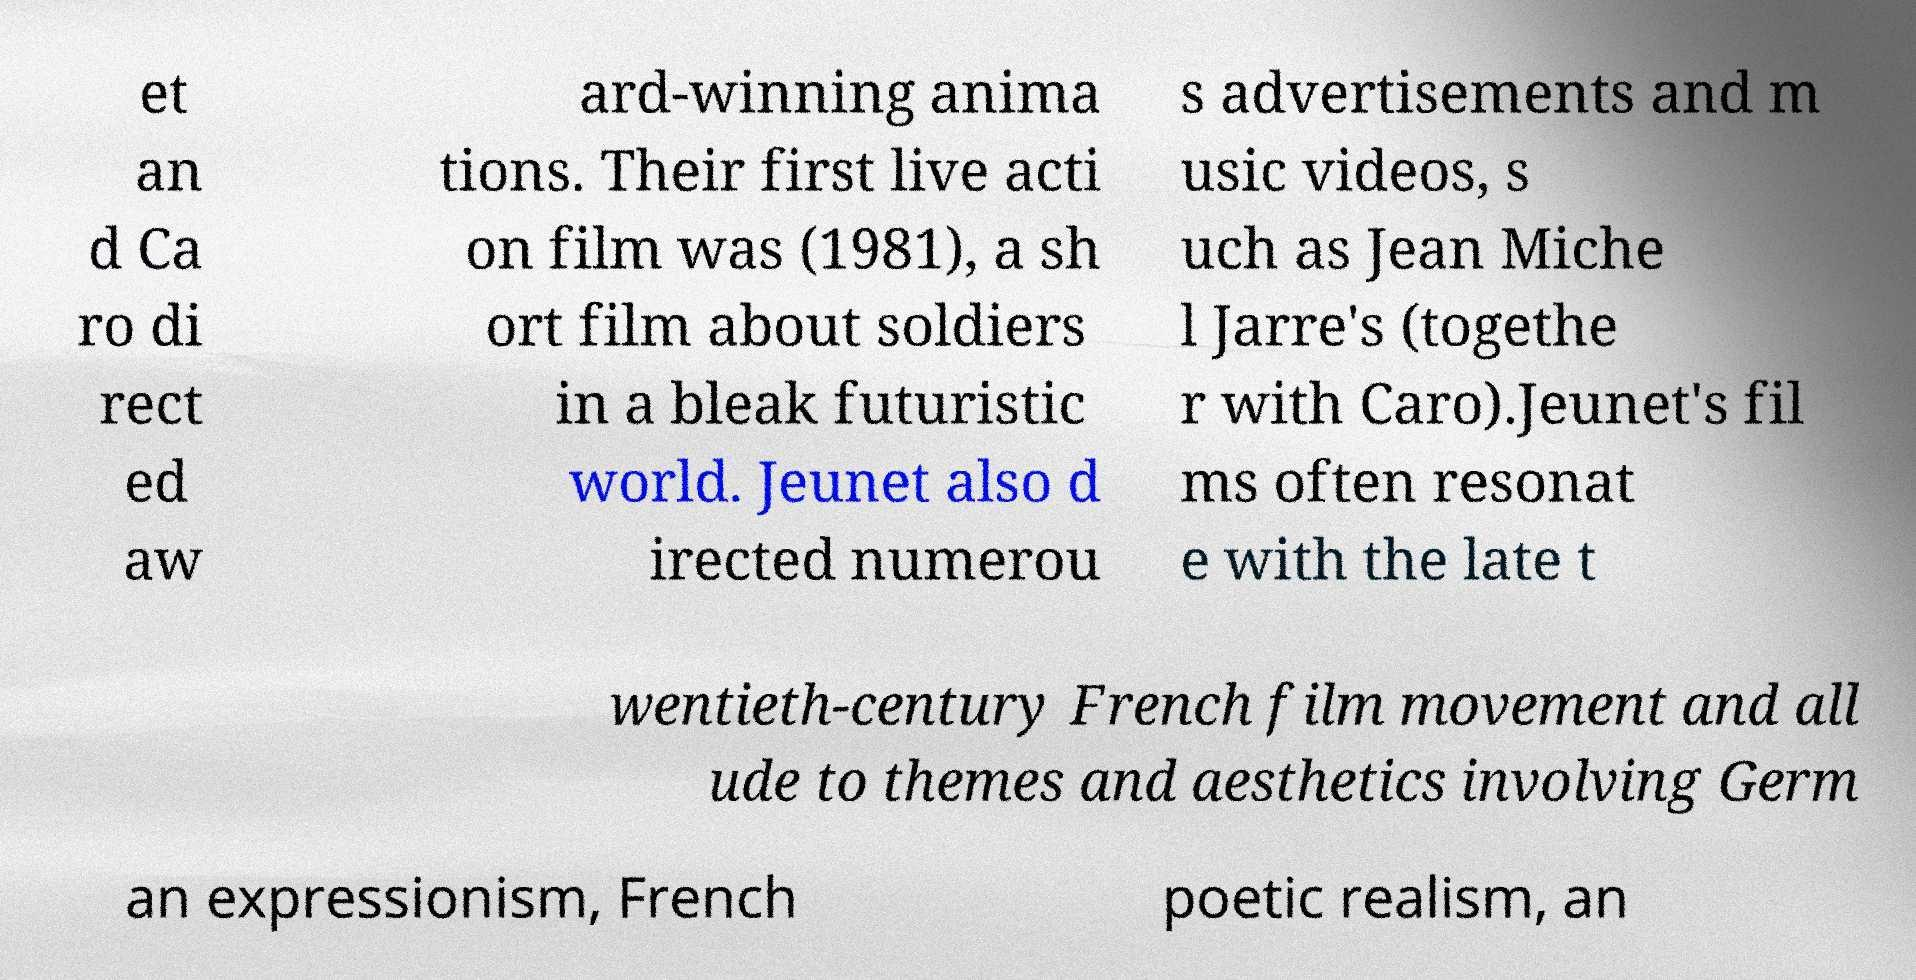Could you assist in decoding the text presented in this image and type it out clearly? et an d Ca ro di rect ed aw ard-winning anima tions. Their first live acti on film was (1981), a sh ort film about soldiers in a bleak futuristic world. Jeunet also d irected numerou s advertisements and m usic videos, s uch as Jean Miche l Jarre's (togethe r with Caro).Jeunet's fil ms often resonat e with the late t wentieth-century French film movement and all ude to themes and aesthetics involving Germ an expressionism, French poetic realism, an 